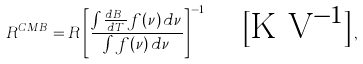Convert formula to latex. <formula><loc_0><loc_0><loc_500><loc_500>R ^ { C M B } = R \left [ { \frac { \int \frac { d B _ { \nu } } { d T } f ( \nu ) \, d \nu } { \int f ( \nu ) \, d \nu } } \right ] ^ { - 1 } \quad \text {[K V$^{-1}$]} ,</formula> 